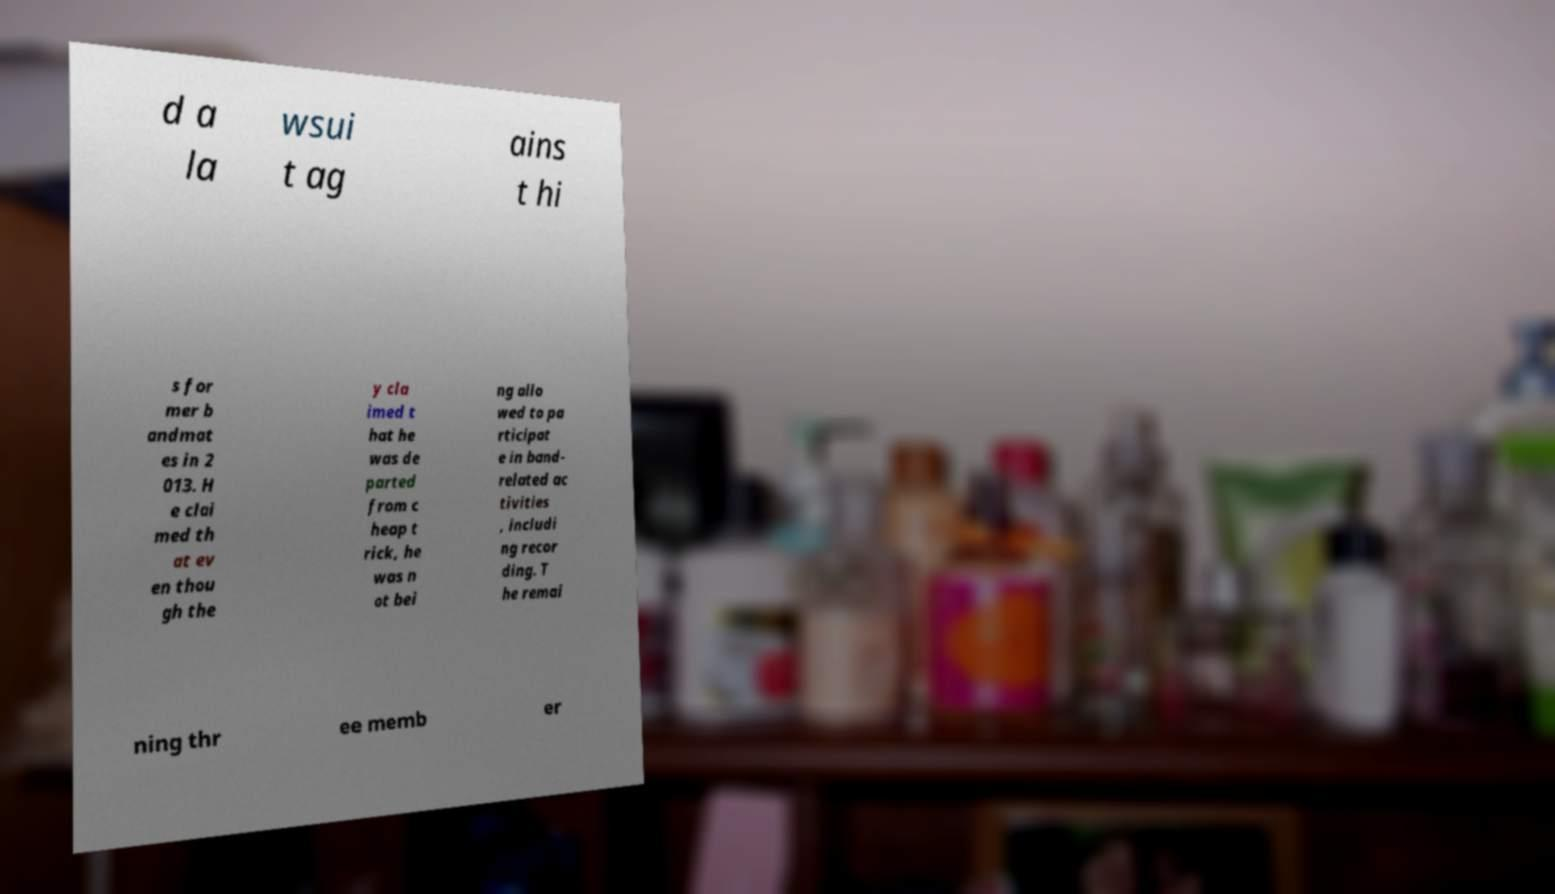Please read and relay the text visible in this image. What does it say? d a la wsui t ag ains t hi s for mer b andmat es in 2 013. H e clai med th at ev en thou gh the y cla imed t hat he was de parted from c heap t rick, he was n ot bei ng allo wed to pa rticipat e in band- related ac tivities , includi ng recor ding. T he remai ning thr ee memb er 